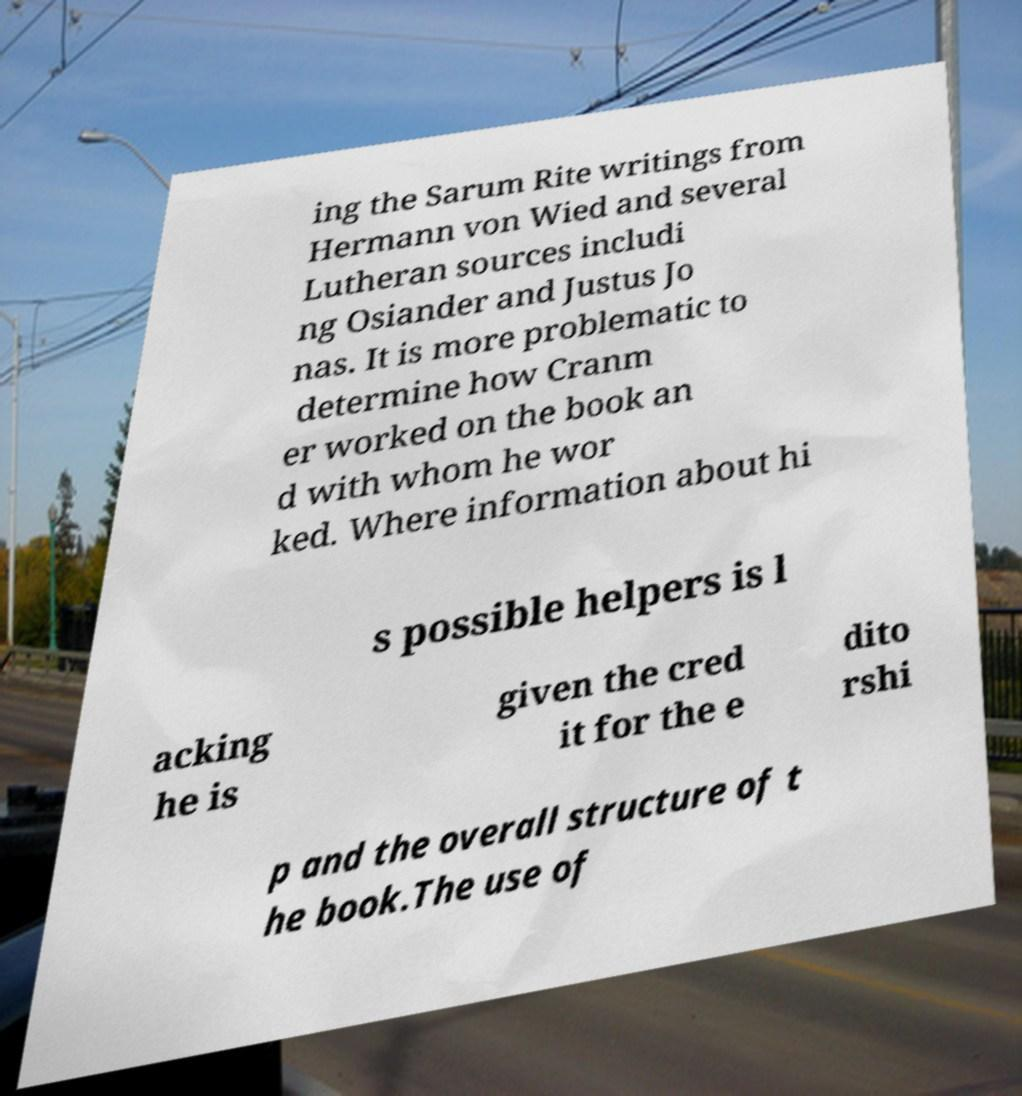Can you accurately transcribe the text from the provided image for me? ing the Sarum Rite writings from Hermann von Wied and several Lutheran sources includi ng Osiander and Justus Jo nas. It is more problematic to determine how Cranm er worked on the book an d with whom he wor ked. Where information about hi s possible helpers is l acking he is given the cred it for the e dito rshi p and the overall structure of t he book.The use of 